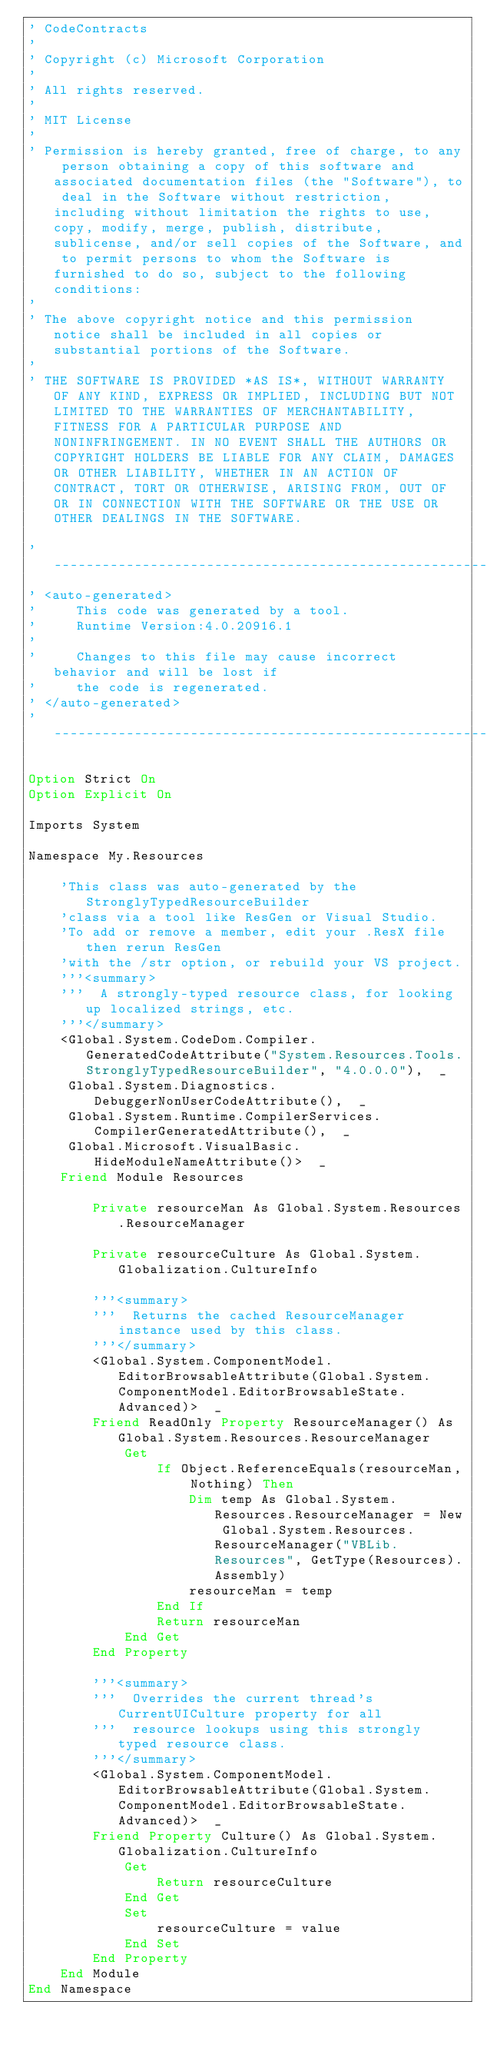<code> <loc_0><loc_0><loc_500><loc_500><_VisualBasic_>' CodeContracts
' 
' Copyright (c) Microsoft Corporation
' 
' All rights reserved. 
' 
' MIT License
' 
' Permission is hereby granted, free of charge, to any person obtaining a copy of this software and associated documentation files (the "Software"), to deal in the Software without restriction, including without limitation the rights to use, copy, modify, merge, publish, distribute, sublicense, and/or sell copies of the Software, and to permit persons to whom the Software is furnished to do so, subject to the following conditions:
' 
' The above copyright notice and this permission notice shall be included in all copies or substantial portions of the Software.
' 
' THE SOFTWARE IS PROVIDED *AS IS*, WITHOUT WARRANTY OF ANY KIND, EXPRESS OR IMPLIED, INCLUDING BUT NOT LIMITED TO THE WARRANTIES OF MERCHANTABILITY, FITNESS FOR A PARTICULAR PURPOSE AND NONINFRINGEMENT. IN NO EVENT SHALL THE AUTHORS OR COPYRIGHT HOLDERS BE LIABLE FOR ANY CLAIM, DAMAGES OR OTHER LIABILITY, WHETHER IN AN ACTION OF CONTRACT, TORT OR OTHERWISE, ARISING FROM, OUT OF OR IN CONNECTION WITH THE SOFTWARE OR THE USE OR OTHER DEALINGS IN THE SOFTWARE.

'------------------------------------------------------------------------------
' <auto-generated>
'     This code was generated by a tool.
'     Runtime Version:4.0.20916.1
'
'     Changes to this file may cause incorrect behavior and will be lost if
'     the code is regenerated.
' </auto-generated>
'------------------------------------------------------------------------------

Option Strict On
Option Explicit On

Imports System

Namespace My.Resources
    
    'This class was auto-generated by the StronglyTypedResourceBuilder
    'class via a tool like ResGen or Visual Studio.
    'To add or remove a member, edit your .ResX file then rerun ResGen
    'with the /str option, or rebuild your VS project.
    '''<summary>
    '''  A strongly-typed resource class, for looking up localized strings, etc.
    '''</summary>
    <Global.System.CodeDom.Compiler.GeneratedCodeAttribute("System.Resources.Tools.StronglyTypedResourceBuilder", "4.0.0.0"),  _
     Global.System.Diagnostics.DebuggerNonUserCodeAttribute(),  _
     Global.System.Runtime.CompilerServices.CompilerGeneratedAttribute(),  _
     Global.Microsoft.VisualBasic.HideModuleNameAttribute()>  _
    Friend Module Resources
        
        Private resourceMan As Global.System.Resources.ResourceManager
        
        Private resourceCulture As Global.System.Globalization.CultureInfo
        
        '''<summary>
        '''  Returns the cached ResourceManager instance used by this class.
        '''</summary>
        <Global.System.ComponentModel.EditorBrowsableAttribute(Global.System.ComponentModel.EditorBrowsableState.Advanced)>  _
        Friend ReadOnly Property ResourceManager() As Global.System.Resources.ResourceManager
            Get
                If Object.ReferenceEquals(resourceMan, Nothing) Then
                    Dim temp As Global.System.Resources.ResourceManager = New Global.System.Resources.ResourceManager("VBLib.Resources", GetType(Resources).Assembly)
                    resourceMan = temp
                End If
                Return resourceMan
            End Get
        End Property
        
        '''<summary>
        '''  Overrides the current thread's CurrentUICulture property for all
        '''  resource lookups using this strongly typed resource class.
        '''</summary>
        <Global.System.ComponentModel.EditorBrowsableAttribute(Global.System.ComponentModel.EditorBrowsableState.Advanced)>  _
        Friend Property Culture() As Global.System.Globalization.CultureInfo
            Get
                Return resourceCulture
            End Get
            Set
                resourceCulture = value
            End Set
        End Property
    End Module
End Namespace
</code> 